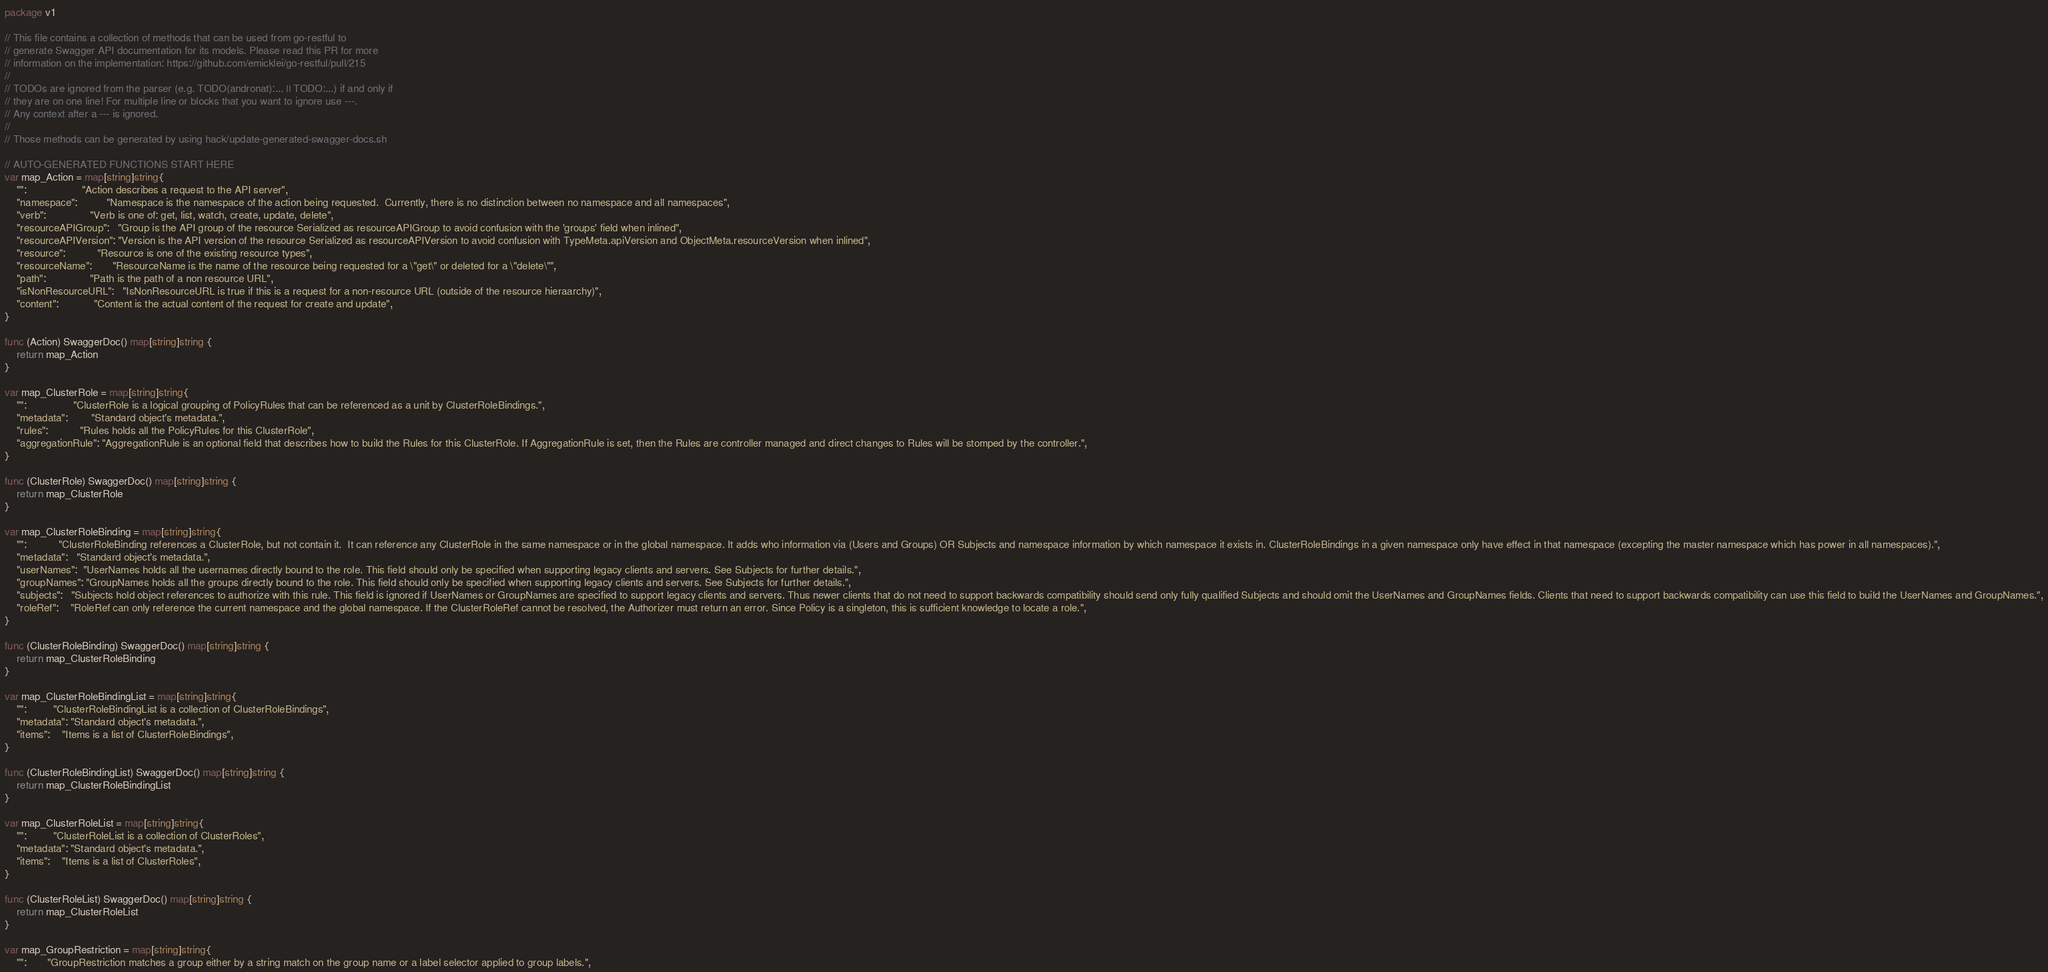Convert code to text. <code><loc_0><loc_0><loc_500><loc_500><_Go_>package v1

// This file contains a collection of methods that can be used from go-restful to
// generate Swagger API documentation for its models. Please read this PR for more
// information on the implementation: https://github.com/emicklei/go-restful/pull/215
//
// TODOs are ignored from the parser (e.g. TODO(andronat):... || TODO:...) if and only if
// they are on one line! For multiple line or blocks that you want to ignore use ---.
// Any context after a --- is ignored.
//
// Those methods can be generated by using hack/update-generated-swagger-docs.sh

// AUTO-GENERATED FUNCTIONS START HERE
var map_Action = map[string]string{
	"":                   "Action describes a request to the API server",
	"namespace":          "Namespace is the namespace of the action being requested.  Currently, there is no distinction between no namespace and all namespaces",
	"verb":               "Verb is one of: get, list, watch, create, update, delete",
	"resourceAPIGroup":   "Group is the API group of the resource Serialized as resourceAPIGroup to avoid confusion with the 'groups' field when inlined",
	"resourceAPIVersion": "Version is the API version of the resource Serialized as resourceAPIVersion to avoid confusion with TypeMeta.apiVersion and ObjectMeta.resourceVersion when inlined",
	"resource":           "Resource is one of the existing resource types",
	"resourceName":       "ResourceName is the name of the resource being requested for a \"get\" or deleted for a \"delete\"",
	"path":               "Path is the path of a non resource URL",
	"isNonResourceURL":   "IsNonResourceURL is true if this is a request for a non-resource URL (outside of the resource hieraarchy)",
	"content":            "Content is the actual content of the request for create and update",
}

func (Action) SwaggerDoc() map[string]string {
	return map_Action
}

var map_ClusterRole = map[string]string{
	"":                "ClusterRole is a logical grouping of PolicyRules that can be referenced as a unit by ClusterRoleBindings.",
	"metadata":        "Standard object's metadata.",
	"rules":           "Rules holds all the PolicyRules for this ClusterRole",
	"aggregationRule": "AggregationRule is an optional field that describes how to build the Rules for this ClusterRole. If AggregationRule is set, then the Rules are controller managed and direct changes to Rules will be stomped by the controller.",
}

func (ClusterRole) SwaggerDoc() map[string]string {
	return map_ClusterRole
}

var map_ClusterRoleBinding = map[string]string{
	"":           "ClusterRoleBinding references a ClusterRole, but not contain it.  It can reference any ClusterRole in the same namespace or in the global namespace. It adds who information via (Users and Groups) OR Subjects and namespace information by which namespace it exists in. ClusterRoleBindings in a given namespace only have effect in that namespace (excepting the master namespace which has power in all namespaces).",
	"metadata":   "Standard object's metadata.",
	"userNames":  "UserNames holds all the usernames directly bound to the role. This field should only be specified when supporting legacy clients and servers. See Subjects for further details.",
	"groupNames": "GroupNames holds all the groups directly bound to the role. This field should only be specified when supporting legacy clients and servers. See Subjects for further details.",
	"subjects":   "Subjects hold object references to authorize with this rule. This field is ignored if UserNames or GroupNames are specified to support legacy clients and servers. Thus newer clients that do not need to support backwards compatibility should send only fully qualified Subjects and should omit the UserNames and GroupNames fields. Clients that need to support backwards compatibility can use this field to build the UserNames and GroupNames.",
	"roleRef":    "RoleRef can only reference the current namespace and the global namespace. If the ClusterRoleRef cannot be resolved, the Authorizer must return an error. Since Policy is a singleton, this is sufficient knowledge to locate a role.",
}

func (ClusterRoleBinding) SwaggerDoc() map[string]string {
	return map_ClusterRoleBinding
}

var map_ClusterRoleBindingList = map[string]string{
	"":         "ClusterRoleBindingList is a collection of ClusterRoleBindings",
	"metadata": "Standard object's metadata.",
	"items":    "Items is a list of ClusterRoleBindings",
}

func (ClusterRoleBindingList) SwaggerDoc() map[string]string {
	return map_ClusterRoleBindingList
}

var map_ClusterRoleList = map[string]string{
	"":         "ClusterRoleList is a collection of ClusterRoles",
	"metadata": "Standard object's metadata.",
	"items":    "Items is a list of ClusterRoles",
}

func (ClusterRoleList) SwaggerDoc() map[string]string {
	return map_ClusterRoleList
}

var map_GroupRestriction = map[string]string{
	"":       "GroupRestriction matches a group either by a string match on the group name or a label selector applied to group labels.",</code> 